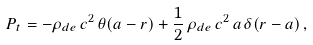<formula> <loc_0><loc_0><loc_500><loc_500>P _ { t } = - \rho _ { d e } \, c ^ { 2 } \, \theta ( a - r ) + \frac { 1 } { 2 } \, \rho _ { d e } \, c ^ { 2 } \, a \, \delta ( r - a ) \, ,</formula> 